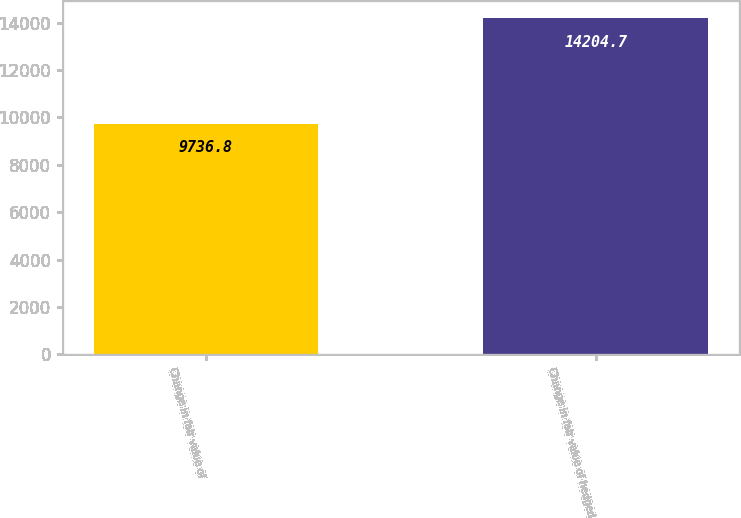<chart> <loc_0><loc_0><loc_500><loc_500><bar_chart><fcel>Change in fair value of<fcel>Change in fair value of hedged<nl><fcel>9736.8<fcel>14204.7<nl></chart> 